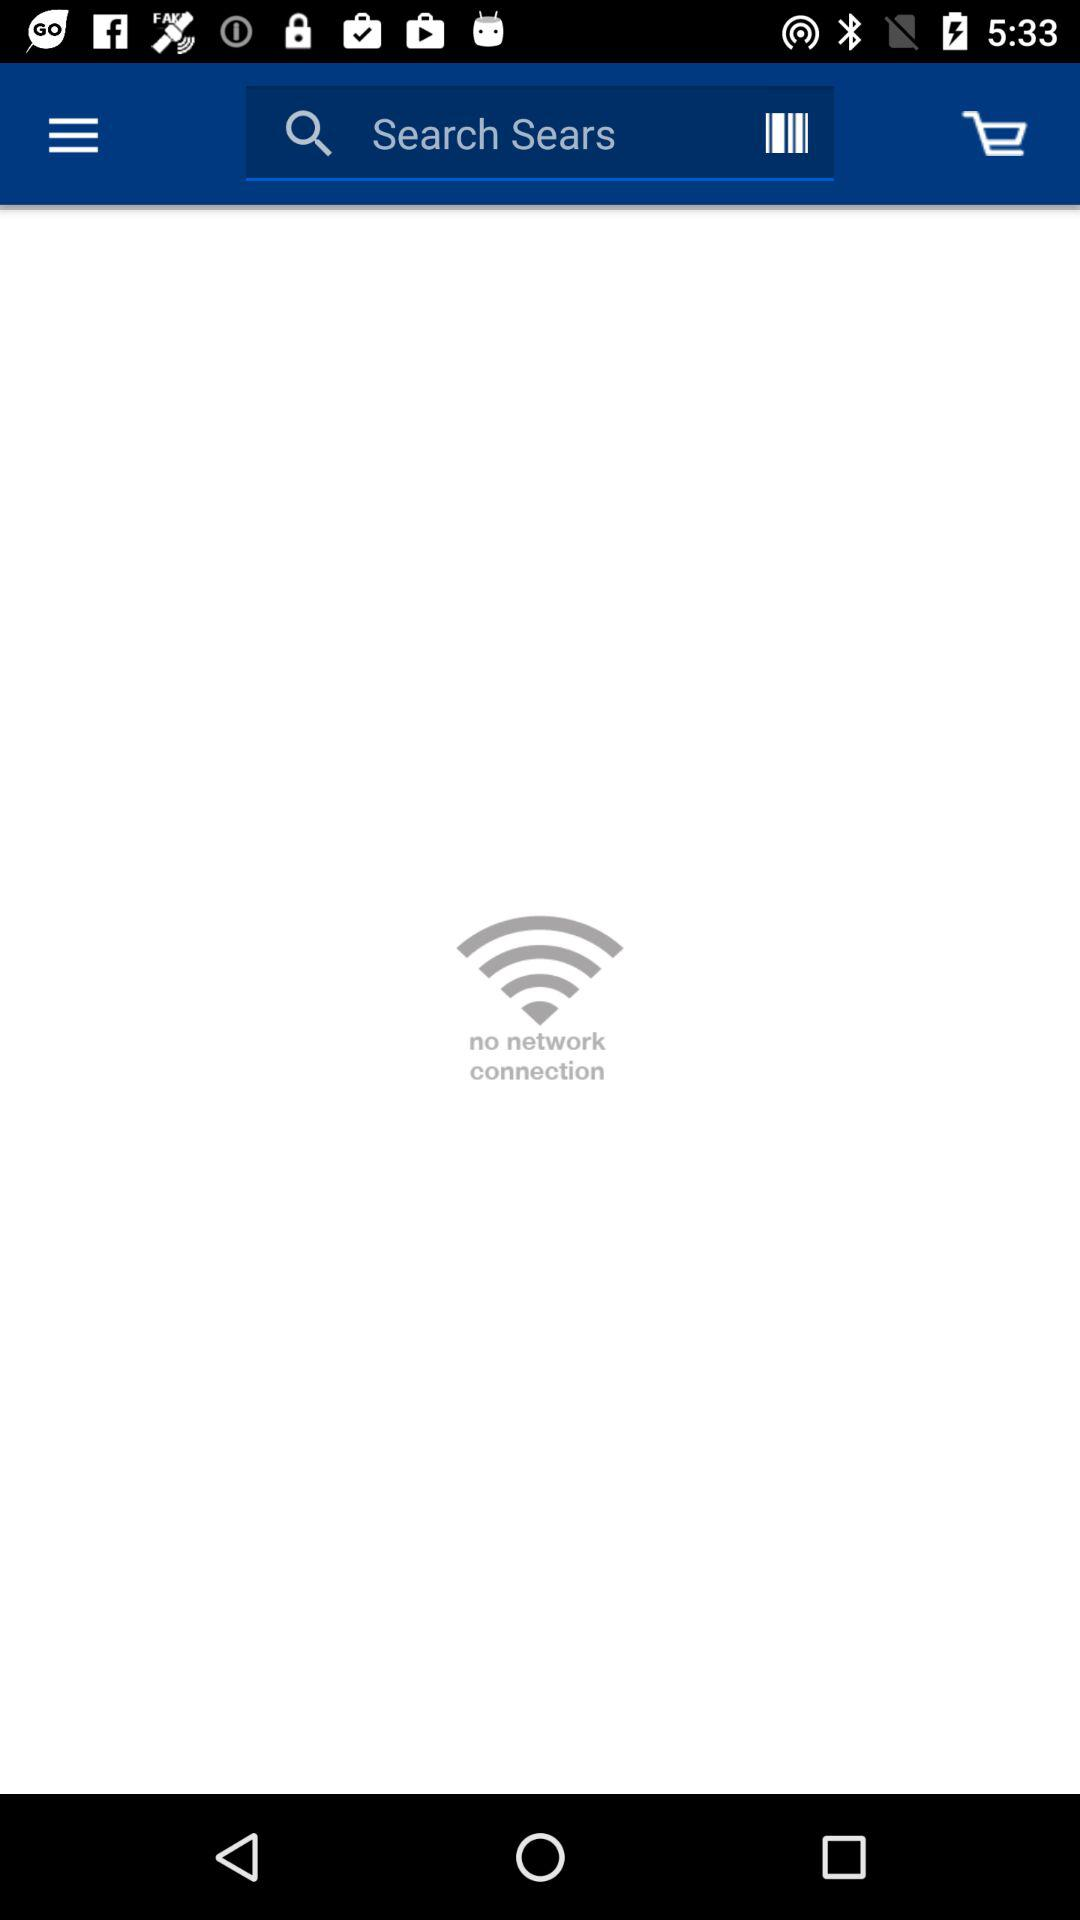Which Sears item is searched?
When the provided information is insufficient, respond with <no answer>. <no answer> 